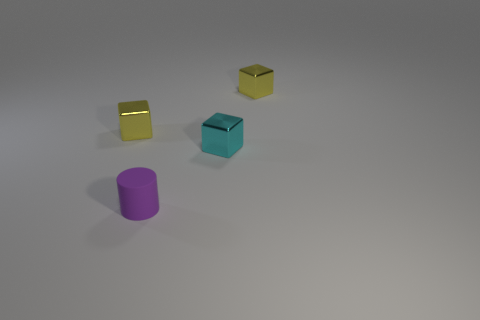What material do the objects in the image look like they're made of? The objects in the image have a smooth and polished look, suggesting they could be made of a material with metallic properties, giving them a reflective and sleek appearance. 